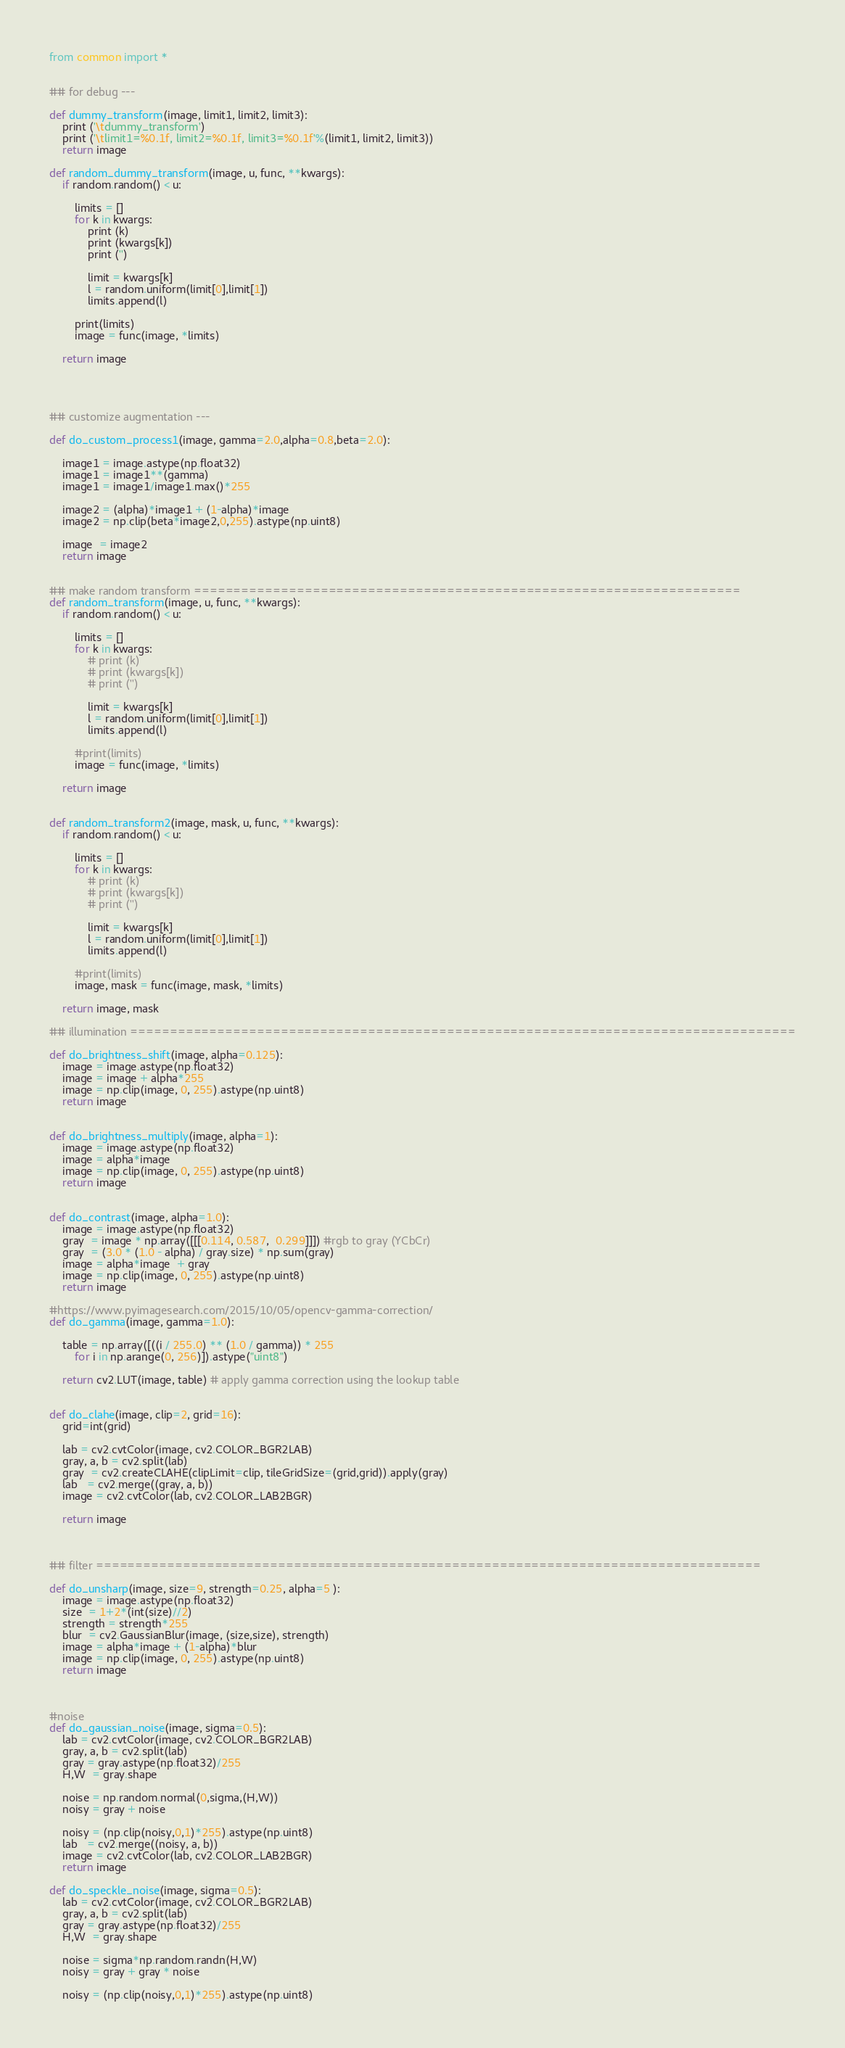Convert code to text. <code><loc_0><loc_0><loc_500><loc_500><_Python_>from common import *


## for debug ---

def dummy_transform(image, limit1, limit2, limit3):
    print ('\tdummy_transform')
    print ('\tlimit1=%0.1f, limit2=%0.1f, limit3=%0.1f'%(limit1, limit2, limit3))
    return image

def random_dummy_transform(image, u, func, **kwargs):
    if random.random() < u:

        limits = []
        for k in kwargs:
            print (k)
            print (kwargs[k])
            print ('')

            limit = kwargs[k]
            l = random.uniform(limit[0],limit[1])
            limits.append(l)

        print(limits)
        image = func(image, *limits)

    return image




## customize augmentation ---

def do_custom_process1(image, gamma=2.0,alpha=0.8,beta=2.0):

    image1 = image.astype(np.float32)
    image1 = image1**(gamma)
    image1 = image1/image1.max()*255

    image2 = (alpha)*image1 + (1-alpha)*image
    image2 = np.clip(beta*image2,0,255).astype(np.uint8)

    image  = image2
    return image


## make random transform =====================================================================
def random_transform(image, u, func, **kwargs):
    if random.random() < u:

        limits = []
        for k in kwargs:
            # print (k)
            # print (kwargs[k])
            # print ('')

            limit = kwargs[k]
            l = random.uniform(limit[0],limit[1])
            limits.append(l)

        #print(limits)
        image = func(image, *limits)

    return image


def random_transform2(image, mask, u, func, **kwargs):
    if random.random() < u:

        limits = []
        for k in kwargs:
            # print (k)
            # print (kwargs[k])
            # print ('')

            limit = kwargs[k]
            l = random.uniform(limit[0],limit[1])
            limits.append(l)

        #print(limits)
        image, mask = func(image, mask, *limits)

    return image, mask

## illumination ====================================================================================

def do_brightness_shift(image, alpha=0.125):
    image = image.astype(np.float32)
    image = image + alpha*255
    image = np.clip(image, 0, 255).astype(np.uint8)
    return image


def do_brightness_multiply(image, alpha=1):
    image = image.astype(np.float32)
    image = alpha*image
    image = np.clip(image, 0, 255).astype(np.uint8)
    return image


def do_contrast(image, alpha=1.0):
    image = image.astype(np.float32)
    gray  = image * np.array([[[0.114, 0.587,  0.299]]]) #rgb to gray (YCbCr)
    gray  = (3.0 * (1.0 - alpha) / gray.size) * np.sum(gray)
    image = alpha*image  + gray
    image = np.clip(image, 0, 255).astype(np.uint8)
    return image

#https://www.pyimagesearch.com/2015/10/05/opencv-gamma-correction/
def do_gamma(image, gamma=1.0):

    table = np.array([((i / 255.0) ** (1.0 / gamma)) * 255
		for i in np.arange(0, 256)]).astype("uint8")

    return cv2.LUT(image, table) # apply gamma correction using the lookup table


def do_clahe(image, clip=2, grid=16):
    grid=int(grid)

    lab = cv2.cvtColor(image, cv2.COLOR_BGR2LAB)
    gray, a, b = cv2.split(lab)
    gray  = cv2.createCLAHE(clipLimit=clip, tileGridSize=(grid,grid)).apply(gray)
    lab   = cv2.merge((gray, a, b))
    image = cv2.cvtColor(lab, cv2.COLOR_LAB2BGR)

    return image



## filter ====================================================================================

def do_unsharp(image, size=9, strength=0.25, alpha=5 ):
    image = image.astype(np.float32)
    size  = 1+2*(int(size)//2)
    strength = strength*255
    blur  = cv2.GaussianBlur(image, (size,size), strength)
    image = alpha*image + (1-alpha)*blur
    image = np.clip(image, 0, 255).astype(np.uint8)
    return image



#noise
def do_gaussian_noise(image, sigma=0.5):
    lab = cv2.cvtColor(image, cv2.COLOR_BGR2LAB)
    gray, a, b = cv2.split(lab)
    gray = gray.astype(np.float32)/255
    H,W  = gray.shape

    noise = np.random.normal(0,sigma,(H,W))
    noisy = gray + noise

    noisy = (np.clip(noisy,0,1)*255).astype(np.uint8)
    lab   = cv2.merge((noisy, a, b))
    image = cv2.cvtColor(lab, cv2.COLOR_LAB2BGR)
    return image

def do_speckle_noise(image, sigma=0.5):
    lab = cv2.cvtColor(image, cv2.COLOR_BGR2LAB)
    gray, a, b = cv2.split(lab)
    gray = gray.astype(np.float32)/255
    H,W  = gray.shape

    noise = sigma*np.random.randn(H,W)
    noisy = gray + gray * noise

    noisy = (np.clip(noisy,0,1)*255).astype(np.uint8)</code> 